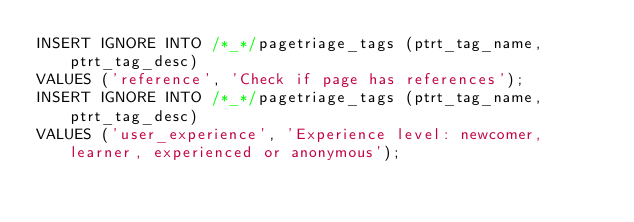Convert code to text. <code><loc_0><loc_0><loc_500><loc_500><_SQL_>INSERT IGNORE INTO /*_*/pagetriage_tags (ptrt_tag_name, ptrt_tag_desc)
VALUES ('reference', 'Check if page has references');
INSERT IGNORE INTO /*_*/pagetriage_tags (ptrt_tag_name, ptrt_tag_desc)
VALUES ('user_experience', 'Experience level: newcomer, learner, experienced or anonymous');
</code> 